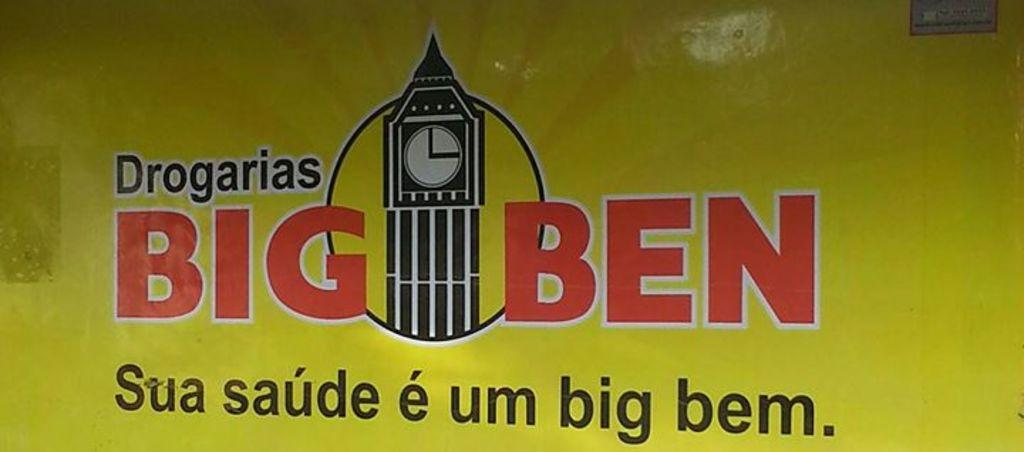What is the main subject of the image? The main subject of the image is an advertisement painting. What structure is located in the center of the image? There is a clock tower in the center of the image. Can you describe the object in the top right corner of the image? Unfortunately, the facts provided do not give enough information to describe the object in the top right corner of the image. How many pets are visible in the image? There are no pets present in the image. What type of lawyer is featured in the advertisement painting? The advertisement painting does not feature a lawyer; it is an advertisement for an unspecified product or service. 